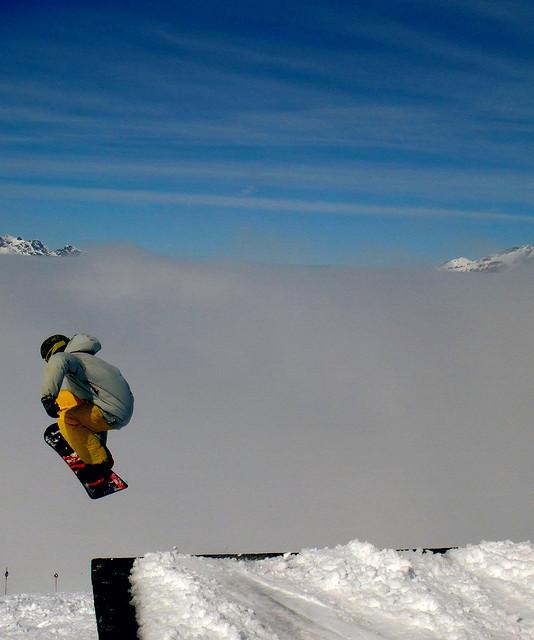How did the man get into the air?
Concise answer only. Ramp. Is this person surfing?
Quick response, please. No. How many people are there?
Keep it brief. 1. What sport is the person doing?
Be succinct. Snowboarding. Does this man wear a hood jacket?
Short answer required. Yes. 